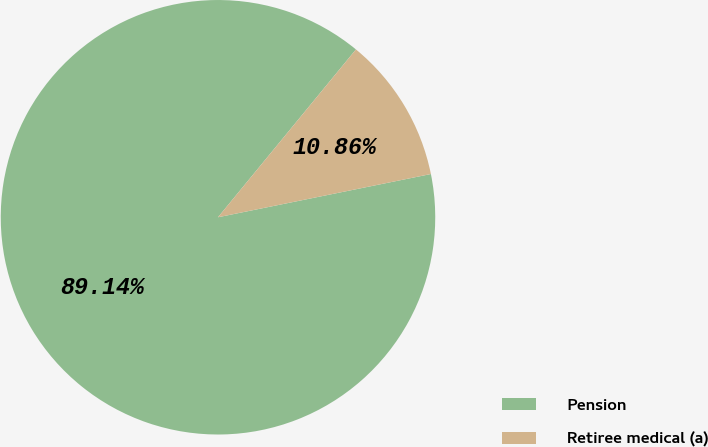<chart> <loc_0><loc_0><loc_500><loc_500><pie_chart><fcel>Pension<fcel>Retiree medical (a)<nl><fcel>89.14%<fcel>10.86%<nl></chart> 